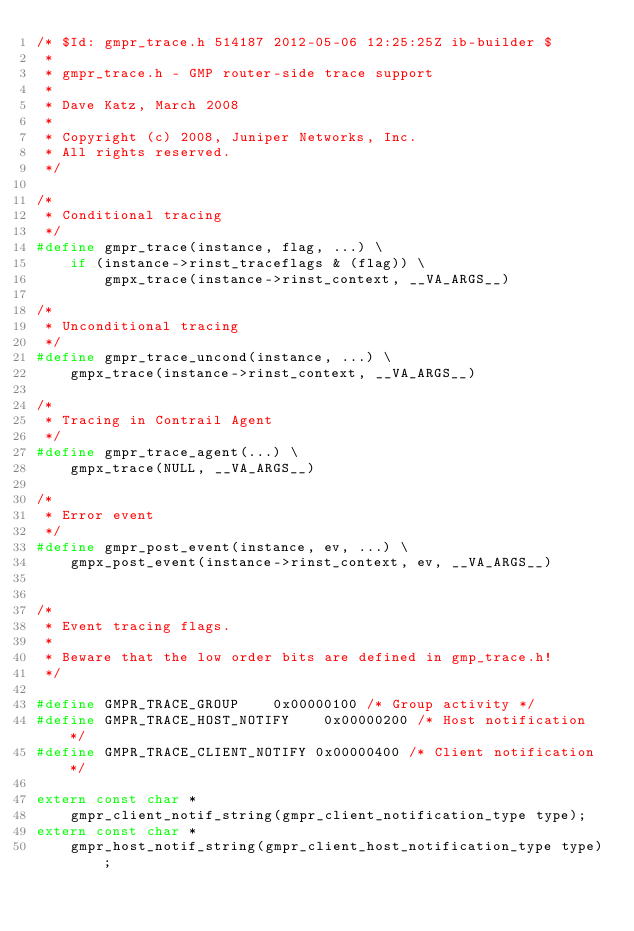Convert code to text. <code><loc_0><loc_0><loc_500><loc_500><_C_>/* $Id: gmpr_trace.h 514187 2012-05-06 12:25:25Z ib-builder $
 *
 * gmpr_trace.h - GMP router-side trace support
 *
 * Dave Katz, March 2008
 *
 * Copyright (c) 2008, Juniper Networks, Inc.
 * All rights reserved.
 */

/*
 * Conditional tracing
 */
#define gmpr_trace(instance, flag, ...) \
    if (instance->rinst_traceflags & (flag)) \
        gmpx_trace(instance->rinst_context, __VA_ARGS__)

/*
 * Unconditional tracing
 */
#define gmpr_trace_uncond(instance, ...) \
    gmpx_trace(instance->rinst_context, __VA_ARGS__)

/*
 * Tracing in Contrail Agent
 */
#define gmpr_trace_agent(...) \
    gmpx_trace(NULL, __VA_ARGS__)

/*
 * Error event
 */
#define gmpr_post_event(instance, ev, ...) \
    gmpx_post_event(instance->rinst_context, ev, __VA_ARGS__)


/*
 * Event tracing flags.
 *
 * Beware that the low order bits are defined in gmp_trace.h!
 */

#define GMPR_TRACE_GROUP    0x00000100 /* Group activity */
#define GMPR_TRACE_HOST_NOTIFY    0x00000200 /* Host notification */
#define GMPR_TRACE_CLIENT_NOTIFY 0x00000400 /* Client notification */

extern const char *
    gmpr_client_notif_string(gmpr_client_notification_type type);
extern const char *
    gmpr_host_notif_string(gmpr_client_host_notification_type type);
</code> 